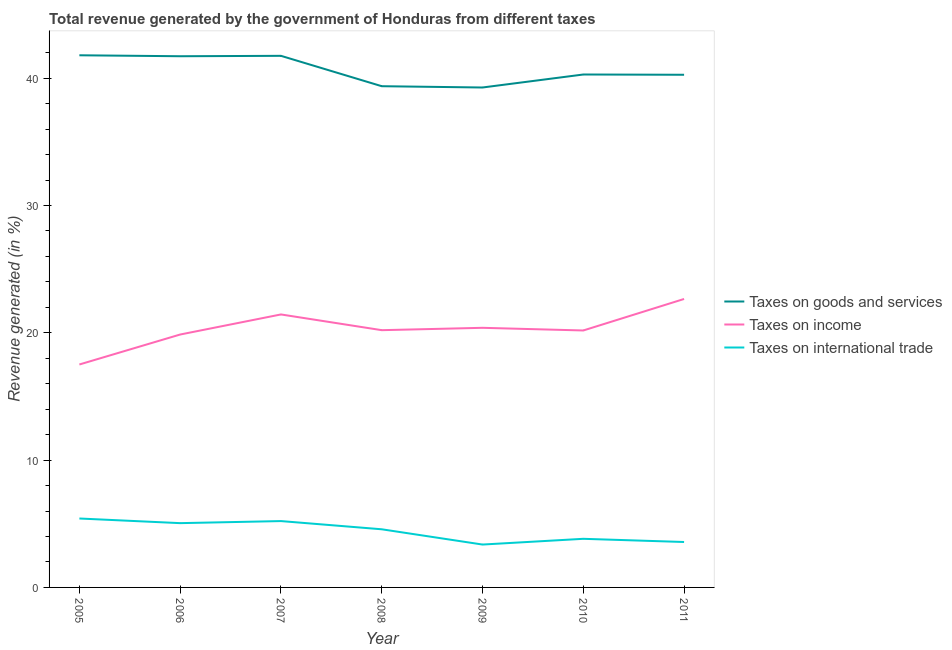How many different coloured lines are there?
Your answer should be compact. 3. Is the number of lines equal to the number of legend labels?
Keep it short and to the point. Yes. What is the percentage of revenue generated by taxes on income in 2009?
Your answer should be compact. 20.39. Across all years, what is the maximum percentage of revenue generated by tax on international trade?
Your answer should be compact. 5.41. Across all years, what is the minimum percentage of revenue generated by taxes on goods and services?
Offer a terse response. 39.27. In which year was the percentage of revenue generated by taxes on goods and services minimum?
Your answer should be compact. 2009. What is the total percentage of revenue generated by taxes on income in the graph?
Offer a very short reply. 142.27. What is the difference between the percentage of revenue generated by taxes on income in 2005 and that in 2008?
Make the answer very short. -2.7. What is the difference between the percentage of revenue generated by taxes on goods and services in 2010 and the percentage of revenue generated by tax on international trade in 2011?
Your response must be concise. 36.73. What is the average percentage of revenue generated by tax on international trade per year?
Offer a terse response. 4.43. In the year 2007, what is the difference between the percentage of revenue generated by taxes on income and percentage of revenue generated by tax on international trade?
Your answer should be very brief. 16.23. What is the ratio of the percentage of revenue generated by taxes on goods and services in 2010 to that in 2011?
Your answer should be compact. 1. Is the difference between the percentage of revenue generated by taxes on goods and services in 2008 and 2009 greater than the difference between the percentage of revenue generated by tax on international trade in 2008 and 2009?
Make the answer very short. No. What is the difference between the highest and the second highest percentage of revenue generated by taxes on income?
Keep it short and to the point. 1.22. What is the difference between the highest and the lowest percentage of revenue generated by tax on international trade?
Your answer should be compact. 2.05. Is it the case that in every year, the sum of the percentage of revenue generated by taxes on goods and services and percentage of revenue generated by taxes on income is greater than the percentage of revenue generated by tax on international trade?
Provide a short and direct response. Yes. Is the percentage of revenue generated by taxes on income strictly less than the percentage of revenue generated by tax on international trade over the years?
Your answer should be compact. No. How many lines are there?
Offer a very short reply. 3. How many years are there in the graph?
Ensure brevity in your answer.  7. Are the values on the major ticks of Y-axis written in scientific E-notation?
Keep it short and to the point. No. Does the graph contain grids?
Ensure brevity in your answer.  No. Where does the legend appear in the graph?
Your answer should be very brief. Center right. How are the legend labels stacked?
Keep it short and to the point. Vertical. What is the title of the graph?
Make the answer very short. Total revenue generated by the government of Honduras from different taxes. Does "Non-communicable diseases" appear as one of the legend labels in the graph?
Your response must be concise. No. What is the label or title of the X-axis?
Your answer should be compact. Year. What is the label or title of the Y-axis?
Provide a succinct answer. Revenue generated (in %). What is the Revenue generated (in %) of Taxes on goods and services in 2005?
Provide a short and direct response. 41.8. What is the Revenue generated (in %) in Taxes on income in 2005?
Offer a very short reply. 17.51. What is the Revenue generated (in %) of Taxes on international trade in 2005?
Your answer should be very brief. 5.41. What is the Revenue generated (in %) of Taxes on goods and services in 2006?
Give a very brief answer. 41.73. What is the Revenue generated (in %) in Taxes on income in 2006?
Your answer should be compact. 19.87. What is the Revenue generated (in %) in Taxes on international trade in 2006?
Give a very brief answer. 5.05. What is the Revenue generated (in %) in Taxes on goods and services in 2007?
Ensure brevity in your answer.  41.76. What is the Revenue generated (in %) of Taxes on income in 2007?
Offer a terse response. 21.44. What is the Revenue generated (in %) in Taxes on international trade in 2007?
Ensure brevity in your answer.  5.21. What is the Revenue generated (in %) of Taxes on goods and services in 2008?
Your answer should be compact. 39.37. What is the Revenue generated (in %) in Taxes on income in 2008?
Make the answer very short. 20.21. What is the Revenue generated (in %) in Taxes on international trade in 2008?
Keep it short and to the point. 4.57. What is the Revenue generated (in %) in Taxes on goods and services in 2009?
Give a very brief answer. 39.27. What is the Revenue generated (in %) of Taxes on income in 2009?
Make the answer very short. 20.39. What is the Revenue generated (in %) of Taxes on international trade in 2009?
Give a very brief answer. 3.37. What is the Revenue generated (in %) of Taxes on goods and services in 2010?
Offer a very short reply. 40.29. What is the Revenue generated (in %) of Taxes on income in 2010?
Provide a succinct answer. 20.19. What is the Revenue generated (in %) in Taxes on international trade in 2010?
Your response must be concise. 3.82. What is the Revenue generated (in %) in Taxes on goods and services in 2011?
Ensure brevity in your answer.  40.27. What is the Revenue generated (in %) in Taxes on income in 2011?
Make the answer very short. 22.66. What is the Revenue generated (in %) in Taxes on international trade in 2011?
Keep it short and to the point. 3.57. Across all years, what is the maximum Revenue generated (in %) in Taxes on goods and services?
Keep it short and to the point. 41.8. Across all years, what is the maximum Revenue generated (in %) in Taxes on income?
Your answer should be very brief. 22.66. Across all years, what is the maximum Revenue generated (in %) of Taxes on international trade?
Offer a terse response. 5.41. Across all years, what is the minimum Revenue generated (in %) in Taxes on goods and services?
Your answer should be compact. 39.27. Across all years, what is the minimum Revenue generated (in %) in Taxes on income?
Give a very brief answer. 17.51. Across all years, what is the minimum Revenue generated (in %) in Taxes on international trade?
Ensure brevity in your answer.  3.37. What is the total Revenue generated (in %) of Taxes on goods and services in the graph?
Your answer should be very brief. 284.51. What is the total Revenue generated (in %) in Taxes on income in the graph?
Provide a short and direct response. 142.27. What is the total Revenue generated (in %) in Taxes on international trade in the graph?
Make the answer very short. 31. What is the difference between the Revenue generated (in %) in Taxes on goods and services in 2005 and that in 2006?
Give a very brief answer. 0.07. What is the difference between the Revenue generated (in %) in Taxes on income in 2005 and that in 2006?
Your answer should be very brief. -2.35. What is the difference between the Revenue generated (in %) in Taxes on international trade in 2005 and that in 2006?
Offer a very short reply. 0.36. What is the difference between the Revenue generated (in %) of Taxes on goods and services in 2005 and that in 2007?
Keep it short and to the point. 0.04. What is the difference between the Revenue generated (in %) of Taxes on income in 2005 and that in 2007?
Ensure brevity in your answer.  -3.93. What is the difference between the Revenue generated (in %) in Taxes on international trade in 2005 and that in 2007?
Give a very brief answer. 0.2. What is the difference between the Revenue generated (in %) of Taxes on goods and services in 2005 and that in 2008?
Ensure brevity in your answer.  2.43. What is the difference between the Revenue generated (in %) of Taxes on income in 2005 and that in 2008?
Offer a terse response. -2.7. What is the difference between the Revenue generated (in %) in Taxes on international trade in 2005 and that in 2008?
Your answer should be very brief. 0.85. What is the difference between the Revenue generated (in %) in Taxes on goods and services in 2005 and that in 2009?
Your answer should be compact. 2.53. What is the difference between the Revenue generated (in %) of Taxes on income in 2005 and that in 2009?
Your answer should be compact. -2.88. What is the difference between the Revenue generated (in %) of Taxes on international trade in 2005 and that in 2009?
Give a very brief answer. 2.05. What is the difference between the Revenue generated (in %) of Taxes on goods and services in 2005 and that in 2010?
Provide a succinct answer. 1.51. What is the difference between the Revenue generated (in %) of Taxes on income in 2005 and that in 2010?
Provide a short and direct response. -2.67. What is the difference between the Revenue generated (in %) in Taxes on international trade in 2005 and that in 2010?
Provide a succinct answer. 1.6. What is the difference between the Revenue generated (in %) of Taxes on goods and services in 2005 and that in 2011?
Provide a short and direct response. 1.53. What is the difference between the Revenue generated (in %) of Taxes on income in 2005 and that in 2011?
Make the answer very short. -5.15. What is the difference between the Revenue generated (in %) of Taxes on international trade in 2005 and that in 2011?
Provide a succinct answer. 1.85. What is the difference between the Revenue generated (in %) of Taxes on goods and services in 2006 and that in 2007?
Keep it short and to the point. -0.03. What is the difference between the Revenue generated (in %) of Taxes on income in 2006 and that in 2007?
Provide a succinct answer. -1.58. What is the difference between the Revenue generated (in %) of Taxes on international trade in 2006 and that in 2007?
Offer a terse response. -0.16. What is the difference between the Revenue generated (in %) of Taxes on goods and services in 2006 and that in 2008?
Ensure brevity in your answer.  2.35. What is the difference between the Revenue generated (in %) of Taxes on income in 2006 and that in 2008?
Your response must be concise. -0.34. What is the difference between the Revenue generated (in %) of Taxes on international trade in 2006 and that in 2008?
Keep it short and to the point. 0.48. What is the difference between the Revenue generated (in %) of Taxes on goods and services in 2006 and that in 2009?
Your answer should be very brief. 2.46. What is the difference between the Revenue generated (in %) in Taxes on income in 2006 and that in 2009?
Your answer should be very brief. -0.53. What is the difference between the Revenue generated (in %) in Taxes on international trade in 2006 and that in 2009?
Give a very brief answer. 1.68. What is the difference between the Revenue generated (in %) of Taxes on goods and services in 2006 and that in 2010?
Offer a terse response. 1.44. What is the difference between the Revenue generated (in %) of Taxes on income in 2006 and that in 2010?
Offer a very short reply. -0.32. What is the difference between the Revenue generated (in %) in Taxes on international trade in 2006 and that in 2010?
Make the answer very short. 1.23. What is the difference between the Revenue generated (in %) in Taxes on goods and services in 2006 and that in 2011?
Provide a succinct answer. 1.46. What is the difference between the Revenue generated (in %) in Taxes on income in 2006 and that in 2011?
Keep it short and to the point. -2.79. What is the difference between the Revenue generated (in %) of Taxes on international trade in 2006 and that in 2011?
Ensure brevity in your answer.  1.48. What is the difference between the Revenue generated (in %) in Taxes on goods and services in 2007 and that in 2008?
Your response must be concise. 2.39. What is the difference between the Revenue generated (in %) in Taxes on income in 2007 and that in 2008?
Your answer should be very brief. 1.23. What is the difference between the Revenue generated (in %) in Taxes on international trade in 2007 and that in 2008?
Offer a terse response. 0.64. What is the difference between the Revenue generated (in %) of Taxes on goods and services in 2007 and that in 2009?
Offer a very short reply. 2.49. What is the difference between the Revenue generated (in %) in Taxes on income in 2007 and that in 2009?
Make the answer very short. 1.05. What is the difference between the Revenue generated (in %) of Taxes on international trade in 2007 and that in 2009?
Provide a succinct answer. 1.84. What is the difference between the Revenue generated (in %) in Taxes on goods and services in 2007 and that in 2010?
Your response must be concise. 1.47. What is the difference between the Revenue generated (in %) of Taxes on income in 2007 and that in 2010?
Provide a short and direct response. 1.26. What is the difference between the Revenue generated (in %) of Taxes on international trade in 2007 and that in 2010?
Provide a short and direct response. 1.39. What is the difference between the Revenue generated (in %) in Taxes on goods and services in 2007 and that in 2011?
Ensure brevity in your answer.  1.49. What is the difference between the Revenue generated (in %) in Taxes on income in 2007 and that in 2011?
Offer a terse response. -1.22. What is the difference between the Revenue generated (in %) of Taxes on international trade in 2007 and that in 2011?
Give a very brief answer. 1.64. What is the difference between the Revenue generated (in %) in Taxes on goods and services in 2008 and that in 2009?
Make the answer very short. 0.1. What is the difference between the Revenue generated (in %) in Taxes on income in 2008 and that in 2009?
Your response must be concise. -0.18. What is the difference between the Revenue generated (in %) of Taxes on international trade in 2008 and that in 2009?
Offer a terse response. 1.2. What is the difference between the Revenue generated (in %) of Taxes on goods and services in 2008 and that in 2010?
Make the answer very short. -0.92. What is the difference between the Revenue generated (in %) in Taxes on income in 2008 and that in 2010?
Offer a very short reply. 0.02. What is the difference between the Revenue generated (in %) in Taxes on international trade in 2008 and that in 2010?
Offer a very short reply. 0.75. What is the difference between the Revenue generated (in %) of Taxes on goods and services in 2008 and that in 2011?
Make the answer very short. -0.9. What is the difference between the Revenue generated (in %) of Taxes on income in 2008 and that in 2011?
Keep it short and to the point. -2.45. What is the difference between the Revenue generated (in %) of Taxes on goods and services in 2009 and that in 2010?
Your answer should be very brief. -1.02. What is the difference between the Revenue generated (in %) of Taxes on income in 2009 and that in 2010?
Offer a terse response. 0.21. What is the difference between the Revenue generated (in %) in Taxes on international trade in 2009 and that in 2010?
Offer a terse response. -0.45. What is the difference between the Revenue generated (in %) of Taxes on goods and services in 2009 and that in 2011?
Your answer should be very brief. -1. What is the difference between the Revenue generated (in %) in Taxes on income in 2009 and that in 2011?
Offer a very short reply. -2.27. What is the difference between the Revenue generated (in %) of Taxes on international trade in 2009 and that in 2011?
Offer a very short reply. -0.2. What is the difference between the Revenue generated (in %) in Taxes on goods and services in 2010 and that in 2011?
Your answer should be compact. 0.02. What is the difference between the Revenue generated (in %) of Taxes on income in 2010 and that in 2011?
Make the answer very short. -2.48. What is the difference between the Revenue generated (in %) in Taxes on international trade in 2010 and that in 2011?
Keep it short and to the point. 0.25. What is the difference between the Revenue generated (in %) of Taxes on goods and services in 2005 and the Revenue generated (in %) of Taxes on income in 2006?
Offer a terse response. 21.94. What is the difference between the Revenue generated (in %) in Taxes on goods and services in 2005 and the Revenue generated (in %) in Taxes on international trade in 2006?
Offer a very short reply. 36.75. What is the difference between the Revenue generated (in %) in Taxes on income in 2005 and the Revenue generated (in %) in Taxes on international trade in 2006?
Make the answer very short. 12.46. What is the difference between the Revenue generated (in %) of Taxes on goods and services in 2005 and the Revenue generated (in %) of Taxes on income in 2007?
Your answer should be very brief. 20.36. What is the difference between the Revenue generated (in %) of Taxes on goods and services in 2005 and the Revenue generated (in %) of Taxes on international trade in 2007?
Give a very brief answer. 36.59. What is the difference between the Revenue generated (in %) in Taxes on income in 2005 and the Revenue generated (in %) in Taxes on international trade in 2007?
Provide a succinct answer. 12.3. What is the difference between the Revenue generated (in %) of Taxes on goods and services in 2005 and the Revenue generated (in %) of Taxes on income in 2008?
Ensure brevity in your answer.  21.59. What is the difference between the Revenue generated (in %) in Taxes on goods and services in 2005 and the Revenue generated (in %) in Taxes on international trade in 2008?
Give a very brief answer. 37.24. What is the difference between the Revenue generated (in %) of Taxes on income in 2005 and the Revenue generated (in %) of Taxes on international trade in 2008?
Provide a succinct answer. 12.95. What is the difference between the Revenue generated (in %) in Taxes on goods and services in 2005 and the Revenue generated (in %) in Taxes on income in 2009?
Provide a succinct answer. 21.41. What is the difference between the Revenue generated (in %) of Taxes on goods and services in 2005 and the Revenue generated (in %) of Taxes on international trade in 2009?
Offer a terse response. 38.43. What is the difference between the Revenue generated (in %) of Taxes on income in 2005 and the Revenue generated (in %) of Taxes on international trade in 2009?
Offer a terse response. 14.14. What is the difference between the Revenue generated (in %) of Taxes on goods and services in 2005 and the Revenue generated (in %) of Taxes on income in 2010?
Offer a terse response. 21.62. What is the difference between the Revenue generated (in %) in Taxes on goods and services in 2005 and the Revenue generated (in %) in Taxes on international trade in 2010?
Provide a succinct answer. 37.98. What is the difference between the Revenue generated (in %) in Taxes on income in 2005 and the Revenue generated (in %) in Taxes on international trade in 2010?
Make the answer very short. 13.69. What is the difference between the Revenue generated (in %) in Taxes on goods and services in 2005 and the Revenue generated (in %) in Taxes on income in 2011?
Offer a very short reply. 19.14. What is the difference between the Revenue generated (in %) in Taxes on goods and services in 2005 and the Revenue generated (in %) in Taxes on international trade in 2011?
Offer a terse response. 38.23. What is the difference between the Revenue generated (in %) in Taxes on income in 2005 and the Revenue generated (in %) in Taxes on international trade in 2011?
Offer a very short reply. 13.94. What is the difference between the Revenue generated (in %) in Taxes on goods and services in 2006 and the Revenue generated (in %) in Taxes on income in 2007?
Keep it short and to the point. 20.28. What is the difference between the Revenue generated (in %) of Taxes on goods and services in 2006 and the Revenue generated (in %) of Taxes on international trade in 2007?
Your answer should be compact. 36.52. What is the difference between the Revenue generated (in %) in Taxes on income in 2006 and the Revenue generated (in %) in Taxes on international trade in 2007?
Keep it short and to the point. 14.66. What is the difference between the Revenue generated (in %) in Taxes on goods and services in 2006 and the Revenue generated (in %) in Taxes on income in 2008?
Provide a short and direct response. 21.52. What is the difference between the Revenue generated (in %) of Taxes on goods and services in 2006 and the Revenue generated (in %) of Taxes on international trade in 2008?
Offer a very short reply. 37.16. What is the difference between the Revenue generated (in %) in Taxes on income in 2006 and the Revenue generated (in %) in Taxes on international trade in 2008?
Give a very brief answer. 15.3. What is the difference between the Revenue generated (in %) in Taxes on goods and services in 2006 and the Revenue generated (in %) in Taxes on income in 2009?
Provide a succinct answer. 21.33. What is the difference between the Revenue generated (in %) of Taxes on goods and services in 2006 and the Revenue generated (in %) of Taxes on international trade in 2009?
Your response must be concise. 38.36. What is the difference between the Revenue generated (in %) in Taxes on income in 2006 and the Revenue generated (in %) in Taxes on international trade in 2009?
Provide a short and direct response. 16.5. What is the difference between the Revenue generated (in %) in Taxes on goods and services in 2006 and the Revenue generated (in %) in Taxes on income in 2010?
Provide a succinct answer. 21.54. What is the difference between the Revenue generated (in %) of Taxes on goods and services in 2006 and the Revenue generated (in %) of Taxes on international trade in 2010?
Your answer should be very brief. 37.91. What is the difference between the Revenue generated (in %) of Taxes on income in 2006 and the Revenue generated (in %) of Taxes on international trade in 2010?
Make the answer very short. 16.05. What is the difference between the Revenue generated (in %) of Taxes on goods and services in 2006 and the Revenue generated (in %) of Taxes on income in 2011?
Give a very brief answer. 19.07. What is the difference between the Revenue generated (in %) of Taxes on goods and services in 2006 and the Revenue generated (in %) of Taxes on international trade in 2011?
Keep it short and to the point. 38.16. What is the difference between the Revenue generated (in %) of Taxes on income in 2006 and the Revenue generated (in %) of Taxes on international trade in 2011?
Keep it short and to the point. 16.3. What is the difference between the Revenue generated (in %) of Taxes on goods and services in 2007 and the Revenue generated (in %) of Taxes on income in 2008?
Make the answer very short. 21.55. What is the difference between the Revenue generated (in %) in Taxes on goods and services in 2007 and the Revenue generated (in %) in Taxes on international trade in 2008?
Your answer should be compact. 37.19. What is the difference between the Revenue generated (in %) in Taxes on income in 2007 and the Revenue generated (in %) in Taxes on international trade in 2008?
Give a very brief answer. 16.88. What is the difference between the Revenue generated (in %) of Taxes on goods and services in 2007 and the Revenue generated (in %) of Taxes on income in 2009?
Keep it short and to the point. 21.37. What is the difference between the Revenue generated (in %) in Taxes on goods and services in 2007 and the Revenue generated (in %) in Taxes on international trade in 2009?
Keep it short and to the point. 38.39. What is the difference between the Revenue generated (in %) of Taxes on income in 2007 and the Revenue generated (in %) of Taxes on international trade in 2009?
Keep it short and to the point. 18.08. What is the difference between the Revenue generated (in %) in Taxes on goods and services in 2007 and the Revenue generated (in %) in Taxes on income in 2010?
Offer a terse response. 21.58. What is the difference between the Revenue generated (in %) of Taxes on goods and services in 2007 and the Revenue generated (in %) of Taxes on international trade in 2010?
Ensure brevity in your answer.  37.94. What is the difference between the Revenue generated (in %) in Taxes on income in 2007 and the Revenue generated (in %) in Taxes on international trade in 2010?
Your answer should be compact. 17.63. What is the difference between the Revenue generated (in %) of Taxes on goods and services in 2007 and the Revenue generated (in %) of Taxes on income in 2011?
Offer a terse response. 19.1. What is the difference between the Revenue generated (in %) in Taxes on goods and services in 2007 and the Revenue generated (in %) in Taxes on international trade in 2011?
Make the answer very short. 38.19. What is the difference between the Revenue generated (in %) in Taxes on income in 2007 and the Revenue generated (in %) in Taxes on international trade in 2011?
Your answer should be compact. 17.88. What is the difference between the Revenue generated (in %) of Taxes on goods and services in 2008 and the Revenue generated (in %) of Taxes on income in 2009?
Your answer should be very brief. 18.98. What is the difference between the Revenue generated (in %) in Taxes on goods and services in 2008 and the Revenue generated (in %) in Taxes on international trade in 2009?
Your answer should be compact. 36.01. What is the difference between the Revenue generated (in %) of Taxes on income in 2008 and the Revenue generated (in %) of Taxes on international trade in 2009?
Ensure brevity in your answer.  16.84. What is the difference between the Revenue generated (in %) in Taxes on goods and services in 2008 and the Revenue generated (in %) in Taxes on income in 2010?
Keep it short and to the point. 19.19. What is the difference between the Revenue generated (in %) in Taxes on goods and services in 2008 and the Revenue generated (in %) in Taxes on international trade in 2010?
Your answer should be compact. 35.56. What is the difference between the Revenue generated (in %) in Taxes on income in 2008 and the Revenue generated (in %) in Taxes on international trade in 2010?
Make the answer very short. 16.39. What is the difference between the Revenue generated (in %) in Taxes on goods and services in 2008 and the Revenue generated (in %) in Taxes on income in 2011?
Ensure brevity in your answer.  16.71. What is the difference between the Revenue generated (in %) in Taxes on goods and services in 2008 and the Revenue generated (in %) in Taxes on international trade in 2011?
Your answer should be compact. 35.81. What is the difference between the Revenue generated (in %) in Taxes on income in 2008 and the Revenue generated (in %) in Taxes on international trade in 2011?
Provide a succinct answer. 16.64. What is the difference between the Revenue generated (in %) of Taxes on goods and services in 2009 and the Revenue generated (in %) of Taxes on income in 2010?
Offer a terse response. 19.09. What is the difference between the Revenue generated (in %) in Taxes on goods and services in 2009 and the Revenue generated (in %) in Taxes on international trade in 2010?
Your answer should be compact. 35.45. What is the difference between the Revenue generated (in %) of Taxes on income in 2009 and the Revenue generated (in %) of Taxes on international trade in 2010?
Give a very brief answer. 16.58. What is the difference between the Revenue generated (in %) of Taxes on goods and services in 2009 and the Revenue generated (in %) of Taxes on income in 2011?
Give a very brief answer. 16.61. What is the difference between the Revenue generated (in %) in Taxes on goods and services in 2009 and the Revenue generated (in %) in Taxes on international trade in 2011?
Keep it short and to the point. 35.7. What is the difference between the Revenue generated (in %) of Taxes on income in 2009 and the Revenue generated (in %) of Taxes on international trade in 2011?
Give a very brief answer. 16.83. What is the difference between the Revenue generated (in %) of Taxes on goods and services in 2010 and the Revenue generated (in %) of Taxes on income in 2011?
Provide a short and direct response. 17.63. What is the difference between the Revenue generated (in %) of Taxes on goods and services in 2010 and the Revenue generated (in %) of Taxes on international trade in 2011?
Keep it short and to the point. 36.73. What is the difference between the Revenue generated (in %) of Taxes on income in 2010 and the Revenue generated (in %) of Taxes on international trade in 2011?
Provide a succinct answer. 16.62. What is the average Revenue generated (in %) in Taxes on goods and services per year?
Give a very brief answer. 40.64. What is the average Revenue generated (in %) in Taxes on income per year?
Offer a very short reply. 20.32. What is the average Revenue generated (in %) in Taxes on international trade per year?
Make the answer very short. 4.43. In the year 2005, what is the difference between the Revenue generated (in %) in Taxes on goods and services and Revenue generated (in %) in Taxes on income?
Keep it short and to the point. 24.29. In the year 2005, what is the difference between the Revenue generated (in %) in Taxes on goods and services and Revenue generated (in %) in Taxes on international trade?
Offer a terse response. 36.39. In the year 2005, what is the difference between the Revenue generated (in %) in Taxes on income and Revenue generated (in %) in Taxes on international trade?
Keep it short and to the point. 12.1. In the year 2006, what is the difference between the Revenue generated (in %) in Taxes on goods and services and Revenue generated (in %) in Taxes on income?
Your response must be concise. 21.86. In the year 2006, what is the difference between the Revenue generated (in %) of Taxes on goods and services and Revenue generated (in %) of Taxes on international trade?
Provide a succinct answer. 36.68. In the year 2006, what is the difference between the Revenue generated (in %) in Taxes on income and Revenue generated (in %) in Taxes on international trade?
Make the answer very short. 14.82. In the year 2007, what is the difference between the Revenue generated (in %) of Taxes on goods and services and Revenue generated (in %) of Taxes on income?
Provide a short and direct response. 20.32. In the year 2007, what is the difference between the Revenue generated (in %) of Taxes on goods and services and Revenue generated (in %) of Taxes on international trade?
Offer a terse response. 36.55. In the year 2007, what is the difference between the Revenue generated (in %) of Taxes on income and Revenue generated (in %) of Taxes on international trade?
Offer a terse response. 16.23. In the year 2008, what is the difference between the Revenue generated (in %) in Taxes on goods and services and Revenue generated (in %) in Taxes on income?
Your answer should be very brief. 19.17. In the year 2008, what is the difference between the Revenue generated (in %) in Taxes on goods and services and Revenue generated (in %) in Taxes on international trade?
Give a very brief answer. 34.81. In the year 2008, what is the difference between the Revenue generated (in %) of Taxes on income and Revenue generated (in %) of Taxes on international trade?
Ensure brevity in your answer.  15.64. In the year 2009, what is the difference between the Revenue generated (in %) of Taxes on goods and services and Revenue generated (in %) of Taxes on income?
Make the answer very short. 18.88. In the year 2009, what is the difference between the Revenue generated (in %) of Taxes on goods and services and Revenue generated (in %) of Taxes on international trade?
Offer a very short reply. 35.9. In the year 2009, what is the difference between the Revenue generated (in %) in Taxes on income and Revenue generated (in %) in Taxes on international trade?
Ensure brevity in your answer.  17.03. In the year 2010, what is the difference between the Revenue generated (in %) of Taxes on goods and services and Revenue generated (in %) of Taxes on income?
Offer a very short reply. 20.11. In the year 2010, what is the difference between the Revenue generated (in %) in Taxes on goods and services and Revenue generated (in %) in Taxes on international trade?
Your response must be concise. 36.47. In the year 2010, what is the difference between the Revenue generated (in %) of Taxes on income and Revenue generated (in %) of Taxes on international trade?
Ensure brevity in your answer.  16.37. In the year 2011, what is the difference between the Revenue generated (in %) of Taxes on goods and services and Revenue generated (in %) of Taxes on income?
Keep it short and to the point. 17.61. In the year 2011, what is the difference between the Revenue generated (in %) of Taxes on goods and services and Revenue generated (in %) of Taxes on international trade?
Offer a very short reply. 36.7. In the year 2011, what is the difference between the Revenue generated (in %) in Taxes on income and Revenue generated (in %) in Taxes on international trade?
Offer a very short reply. 19.09. What is the ratio of the Revenue generated (in %) in Taxes on goods and services in 2005 to that in 2006?
Your response must be concise. 1. What is the ratio of the Revenue generated (in %) in Taxes on income in 2005 to that in 2006?
Keep it short and to the point. 0.88. What is the ratio of the Revenue generated (in %) in Taxes on international trade in 2005 to that in 2006?
Provide a succinct answer. 1.07. What is the ratio of the Revenue generated (in %) of Taxes on income in 2005 to that in 2007?
Your response must be concise. 0.82. What is the ratio of the Revenue generated (in %) of Taxes on international trade in 2005 to that in 2007?
Ensure brevity in your answer.  1.04. What is the ratio of the Revenue generated (in %) of Taxes on goods and services in 2005 to that in 2008?
Your answer should be very brief. 1.06. What is the ratio of the Revenue generated (in %) in Taxes on income in 2005 to that in 2008?
Offer a terse response. 0.87. What is the ratio of the Revenue generated (in %) of Taxes on international trade in 2005 to that in 2008?
Give a very brief answer. 1.19. What is the ratio of the Revenue generated (in %) of Taxes on goods and services in 2005 to that in 2009?
Your answer should be very brief. 1.06. What is the ratio of the Revenue generated (in %) of Taxes on income in 2005 to that in 2009?
Your answer should be very brief. 0.86. What is the ratio of the Revenue generated (in %) in Taxes on international trade in 2005 to that in 2009?
Make the answer very short. 1.61. What is the ratio of the Revenue generated (in %) in Taxes on goods and services in 2005 to that in 2010?
Make the answer very short. 1.04. What is the ratio of the Revenue generated (in %) of Taxes on income in 2005 to that in 2010?
Keep it short and to the point. 0.87. What is the ratio of the Revenue generated (in %) of Taxes on international trade in 2005 to that in 2010?
Your answer should be compact. 1.42. What is the ratio of the Revenue generated (in %) of Taxes on goods and services in 2005 to that in 2011?
Offer a very short reply. 1.04. What is the ratio of the Revenue generated (in %) in Taxes on income in 2005 to that in 2011?
Offer a very short reply. 0.77. What is the ratio of the Revenue generated (in %) of Taxes on international trade in 2005 to that in 2011?
Keep it short and to the point. 1.52. What is the ratio of the Revenue generated (in %) of Taxes on goods and services in 2006 to that in 2007?
Offer a terse response. 1. What is the ratio of the Revenue generated (in %) of Taxes on income in 2006 to that in 2007?
Make the answer very short. 0.93. What is the ratio of the Revenue generated (in %) in Taxes on goods and services in 2006 to that in 2008?
Your response must be concise. 1.06. What is the ratio of the Revenue generated (in %) in Taxes on income in 2006 to that in 2008?
Ensure brevity in your answer.  0.98. What is the ratio of the Revenue generated (in %) in Taxes on international trade in 2006 to that in 2008?
Provide a short and direct response. 1.11. What is the ratio of the Revenue generated (in %) in Taxes on income in 2006 to that in 2009?
Your answer should be compact. 0.97. What is the ratio of the Revenue generated (in %) in Taxes on international trade in 2006 to that in 2009?
Make the answer very short. 1.5. What is the ratio of the Revenue generated (in %) of Taxes on goods and services in 2006 to that in 2010?
Your response must be concise. 1.04. What is the ratio of the Revenue generated (in %) of Taxes on income in 2006 to that in 2010?
Your answer should be compact. 0.98. What is the ratio of the Revenue generated (in %) of Taxes on international trade in 2006 to that in 2010?
Ensure brevity in your answer.  1.32. What is the ratio of the Revenue generated (in %) in Taxes on goods and services in 2006 to that in 2011?
Your answer should be very brief. 1.04. What is the ratio of the Revenue generated (in %) of Taxes on income in 2006 to that in 2011?
Provide a succinct answer. 0.88. What is the ratio of the Revenue generated (in %) in Taxes on international trade in 2006 to that in 2011?
Provide a short and direct response. 1.42. What is the ratio of the Revenue generated (in %) of Taxes on goods and services in 2007 to that in 2008?
Give a very brief answer. 1.06. What is the ratio of the Revenue generated (in %) of Taxes on income in 2007 to that in 2008?
Keep it short and to the point. 1.06. What is the ratio of the Revenue generated (in %) of Taxes on international trade in 2007 to that in 2008?
Keep it short and to the point. 1.14. What is the ratio of the Revenue generated (in %) in Taxes on goods and services in 2007 to that in 2009?
Your answer should be compact. 1.06. What is the ratio of the Revenue generated (in %) of Taxes on income in 2007 to that in 2009?
Keep it short and to the point. 1.05. What is the ratio of the Revenue generated (in %) in Taxes on international trade in 2007 to that in 2009?
Make the answer very short. 1.55. What is the ratio of the Revenue generated (in %) in Taxes on goods and services in 2007 to that in 2010?
Provide a succinct answer. 1.04. What is the ratio of the Revenue generated (in %) in Taxes on income in 2007 to that in 2010?
Offer a very short reply. 1.06. What is the ratio of the Revenue generated (in %) in Taxes on international trade in 2007 to that in 2010?
Provide a short and direct response. 1.36. What is the ratio of the Revenue generated (in %) in Taxes on goods and services in 2007 to that in 2011?
Offer a very short reply. 1.04. What is the ratio of the Revenue generated (in %) in Taxes on income in 2007 to that in 2011?
Your response must be concise. 0.95. What is the ratio of the Revenue generated (in %) of Taxes on international trade in 2007 to that in 2011?
Provide a short and direct response. 1.46. What is the ratio of the Revenue generated (in %) in Taxes on income in 2008 to that in 2009?
Give a very brief answer. 0.99. What is the ratio of the Revenue generated (in %) in Taxes on international trade in 2008 to that in 2009?
Provide a succinct answer. 1.36. What is the ratio of the Revenue generated (in %) in Taxes on goods and services in 2008 to that in 2010?
Your answer should be very brief. 0.98. What is the ratio of the Revenue generated (in %) in Taxes on income in 2008 to that in 2010?
Give a very brief answer. 1. What is the ratio of the Revenue generated (in %) of Taxes on international trade in 2008 to that in 2010?
Offer a very short reply. 1.2. What is the ratio of the Revenue generated (in %) of Taxes on goods and services in 2008 to that in 2011?
Make the answer very short. 0.98. What is the ratio of the Revenue generated (in %) in Taxes on income in 2008 to that in 2011?
Provide a succinct answer. 0.89. What is the ratio of the Revenue generated (in %) in Taxes on international trade in 2008 to that in 2011?
Give a very brief answer. 1.28. What is the ratio of the Revenue generated (in %) in Taxes on goods and services in 2009 to that in 2010?
Provide a succinct answer. 0.97. What is the ratio of the Revenue generated (in %) of Taxes on income in 2009 to that in 2010?
Offer a very short reply. 1.01. What is the ratio of the Revenue generated (in %) in Taxes on international trade in 2009 to that in 2010?
Your response must be concise. 0.88. What is the ratio of the Revenue generated (in %) in Taxes on goods and services in 2009 to that in 2011?
Ensure brevity in your answer.  0.98. What is the ratio of the Revenue generated (in %) in Taxes on income in 2009 to that in 2011?
Give a very brief answer. 0.9. What is the ratio of the Revenue generated (in %) in Taxes on international trade in 2009 to that in 2011?
Offer a terse response. 0.94. What is the ratio of the Revenue generated (in %) in Taxes on goods and services in 2010 to that in 2011?
Provide a succinct answer. 1. What is the ratio of the Revenue generated (in %) of Taxes on income in 2010 to that in 2011?
Your answer should be very brief. 0.89. What is the ratio of the Revenue generated (in %) in Taxes on international trade in 2010 to that in 2011?
Provide a short and direct response. 1.07. What is the difference between the highest and the second highest Revenue generated (in %) of Taxes on goods and services?
Your answer should be very brief. 0.04. What is the difference between the highest and the second highest Revenue generated (in %) in Taxes on income?
Keep it short and to the point. 1.22. What is the difference between the highest and the second highest Revenue generated (in %) of Taxes on international trade?
Provide a short and direct response. 0.2. What is the difference between the highest and the lowest Revenue generated (in %) in Taxes on goods and services?
Offer a terse response. 2.53. What is the difference between the highest and the lowest Revenue generated (in %) in Taxes on income?
Keep it short and to the point. 5.15. What is the difference between the highest and the lowest Revenue generated (in %) of Taxes on international trade?
Offer a terse response. 2.05. 